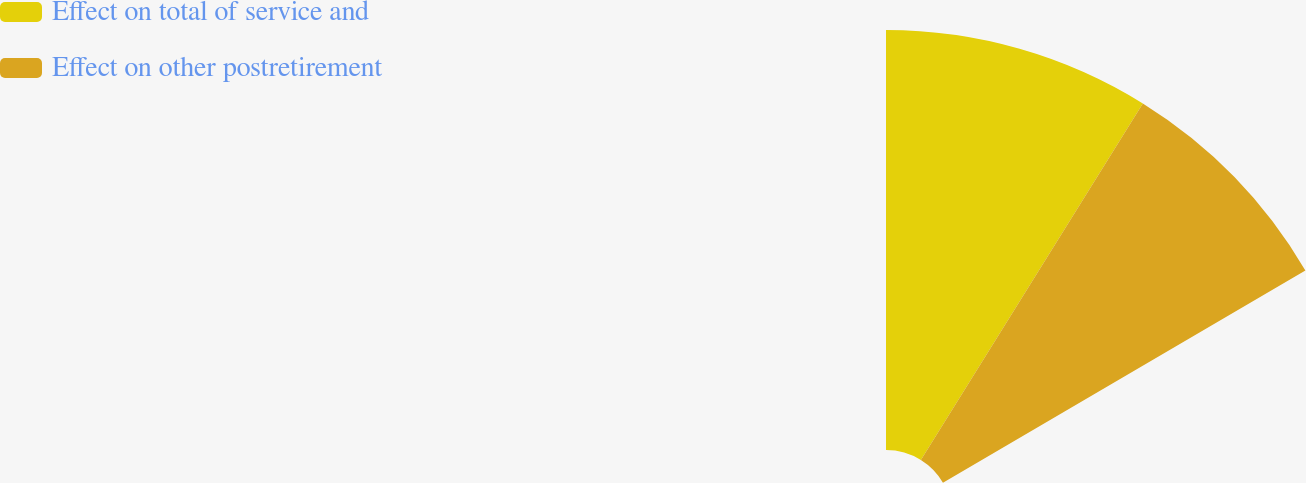Convert chart to OTSL. <chart><loc_0><loc_0><loc_500><loc_500><pie_chart><fcel>Effect on total of service and<fcel>Effect on other postretirement<nl><fcel>53.49%<fcel>46.51%<nl></chart> 